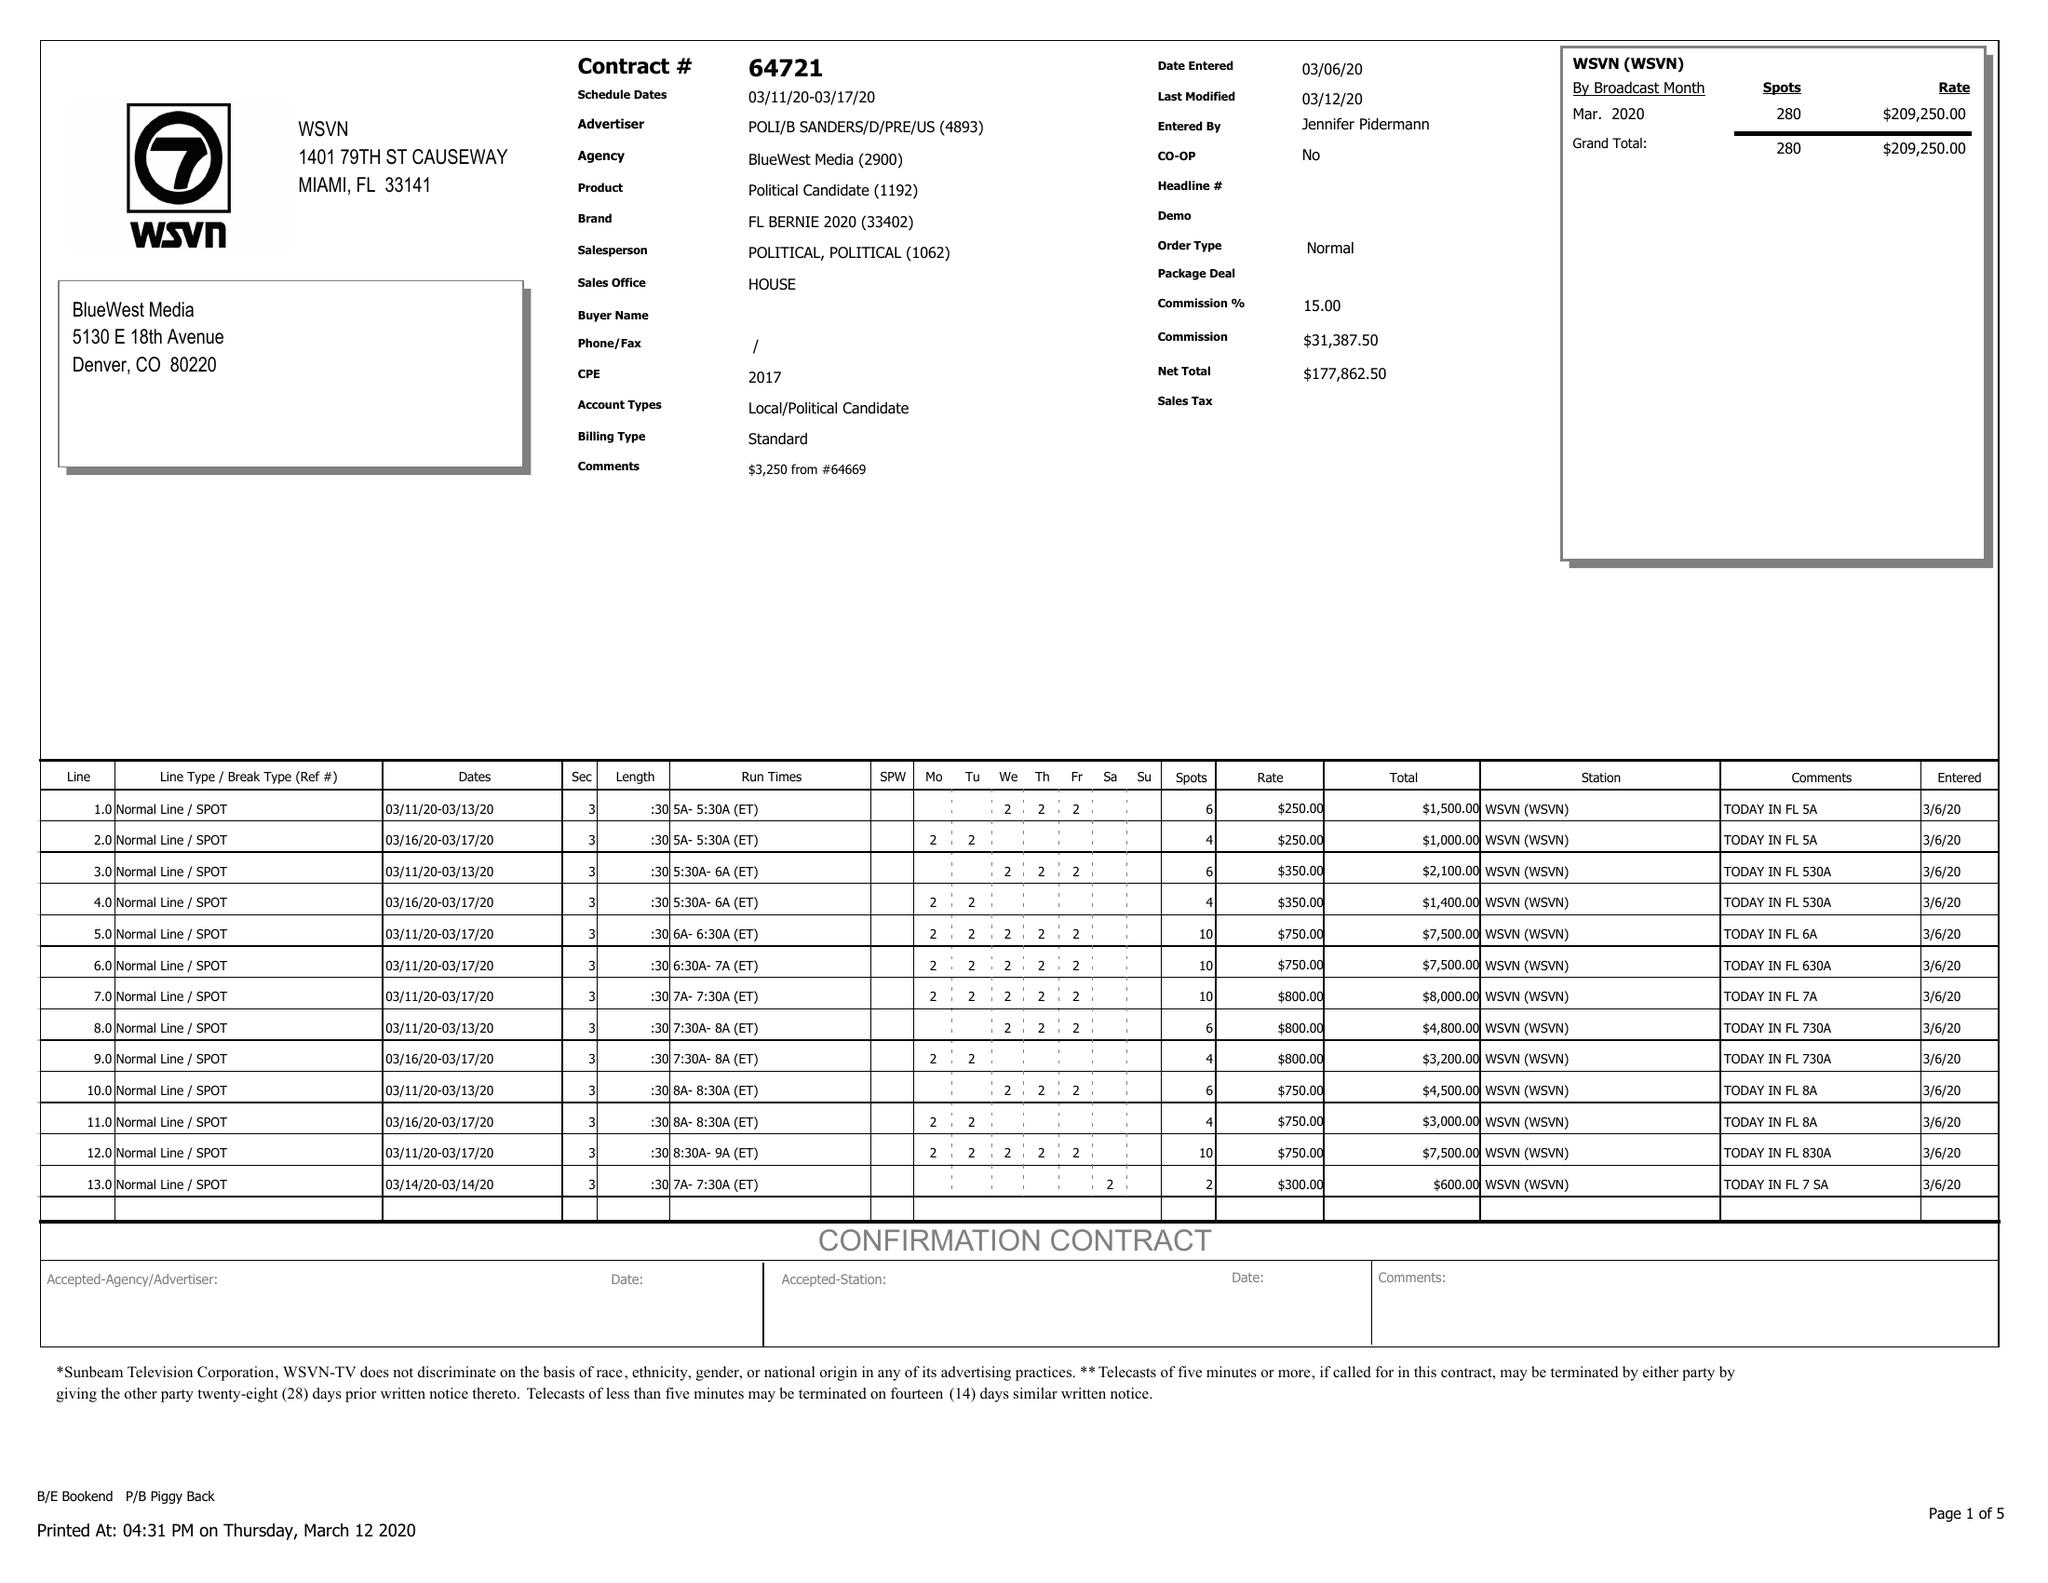What is the value for the flight_from?
Answer the question using a single word or phrase. 03/11/20 